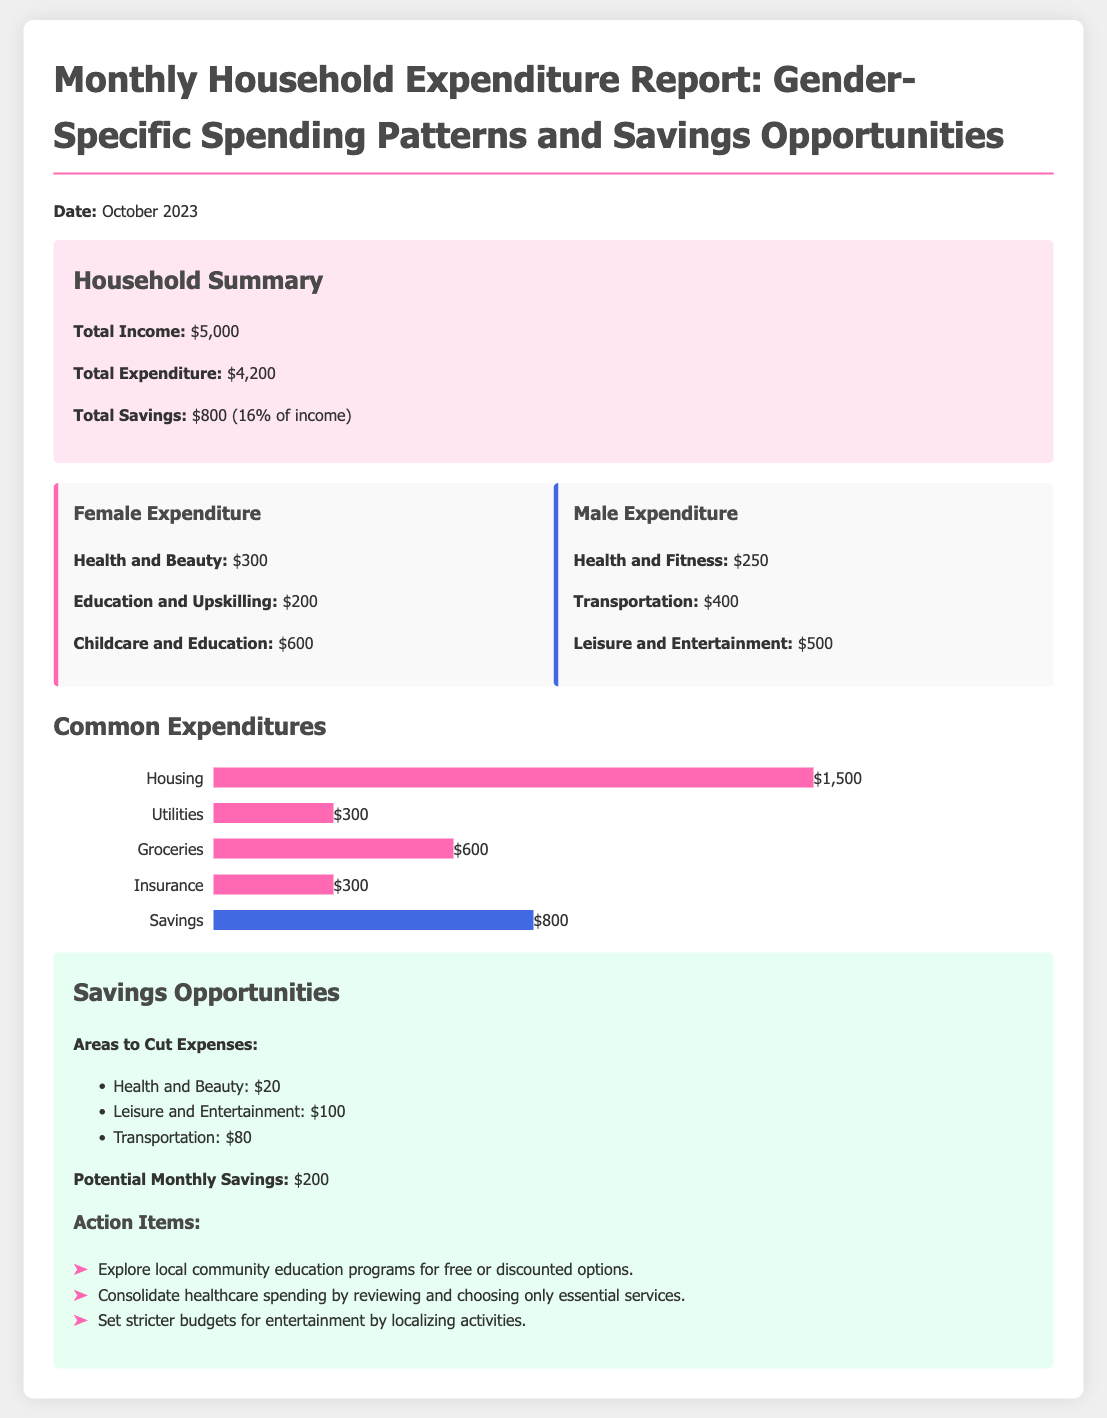What is the total income? The total income is provided in the summary section of the document.
Answer: $5,000 How much did females spend on childcare and education? This information can be found in the gender comparison section specifically under female expenditure.
Answer: $600 What is the total expenditure for the month? The total expenditure is listed in the household summary section of the document.
Answer: $4,200 What is the potential monthly savings listed in the document? Potential monthly savings can be found in the savings opportunities section.
Answer: $200 Which category had the highest expenditure for females? This requires comparing the expenditures listed in the female column to find the highest amount.
Answer: Childcare and Education What percentage of total income is saved? The percentage of savings is calculated from the total income and total savings, as noted in the summary.
Answer: 16% What spending area is suggested for a $100 reduction? The document suggests cutting expenses in specific areas listed under savings opportunities.
Answer: Leisure and Entertainment How much did males spend on transportation? The amount spent by males on transportation is provided under the male expenditure section.
Answer: $400 What is the total amount spent on groceries? The total amount spent on groceries is stated in the common expenditures section.
Answer: $600 